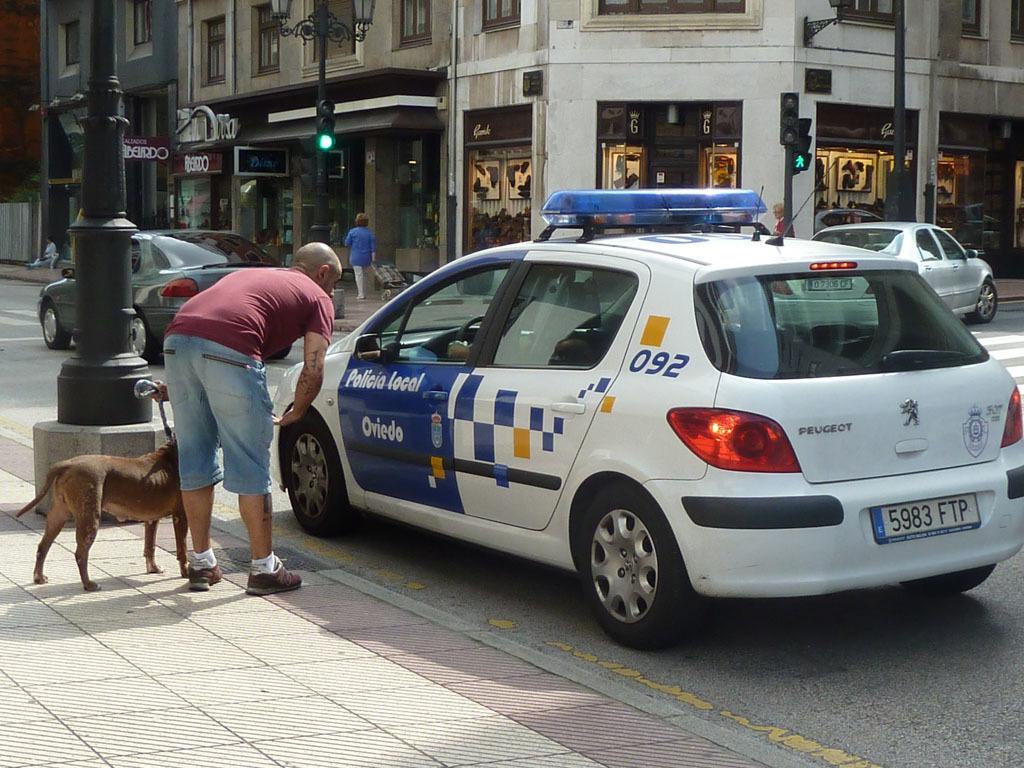Can you describe this image briefly? In the image we can see there is a man who is standing on the footpath with a dog and in front of him there is a car which is parked on the road and there are lot of buildings and traffic signals on the road. 